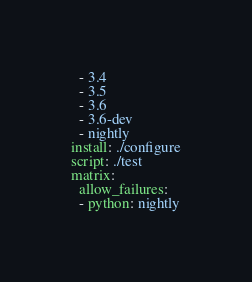<code> <loc_0><loc_0><loc_500><loc_500><_YAML_>  - 3.4
  - 3.5
  - 3.6
  - 3.6-dev
  - nightly
install: ./configure
script: ./test
matrix:
  allow_failures:
  - python: nightly
</code> 